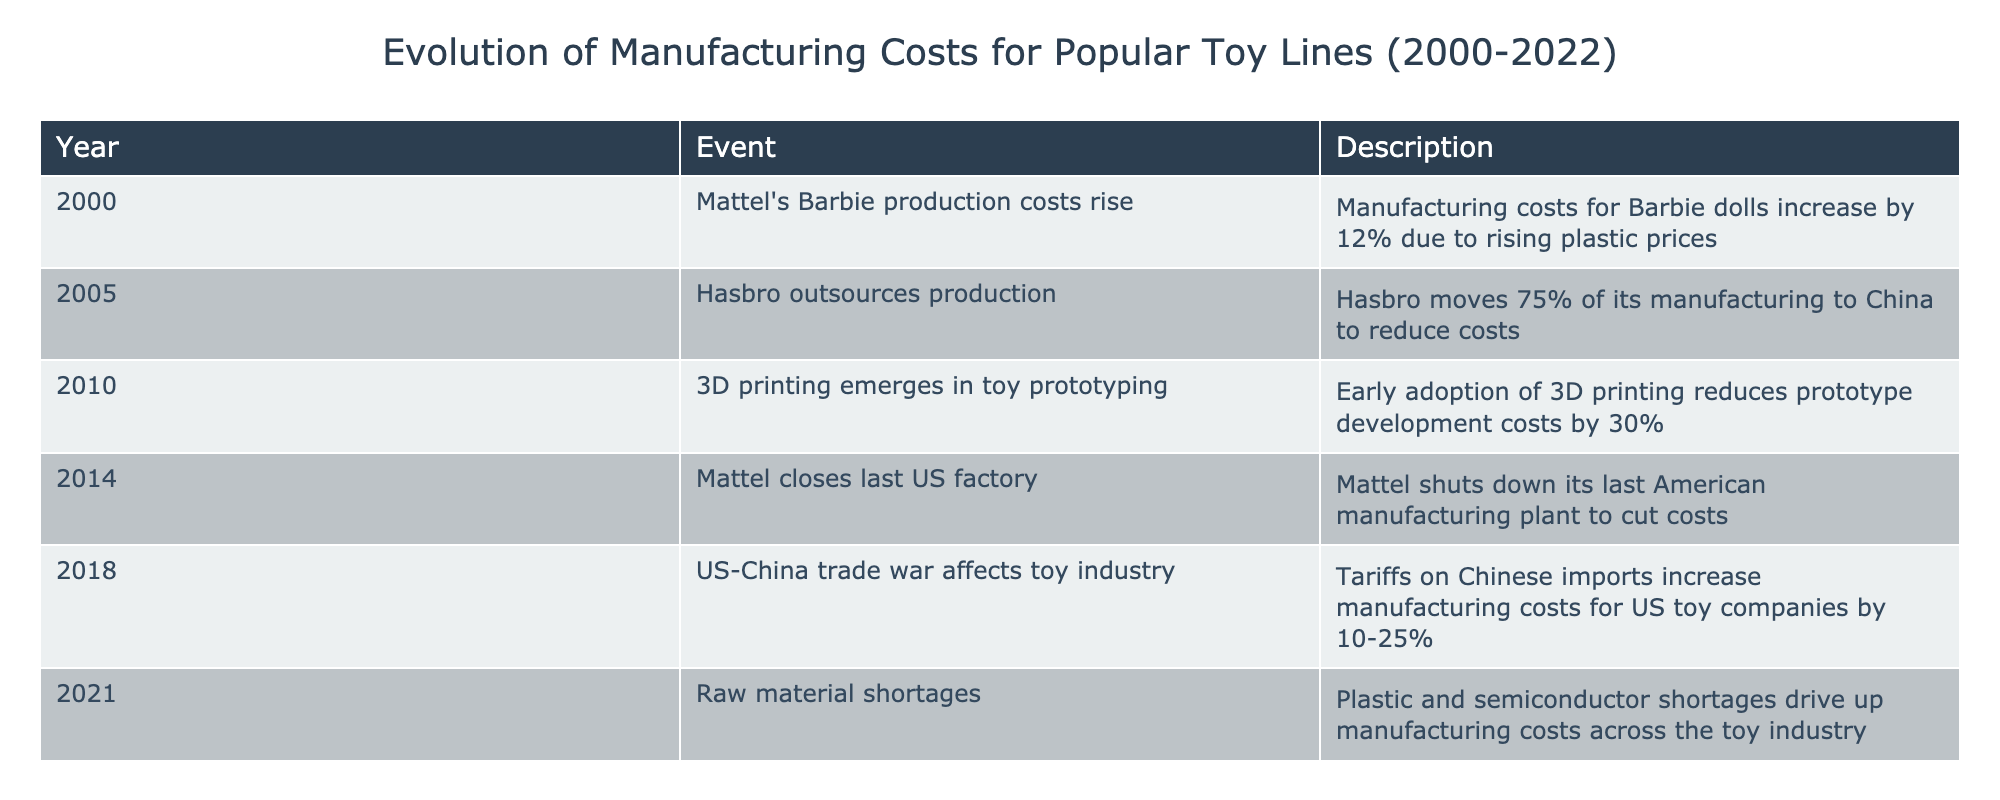What year did Hasbro outsource 75% of its production? Referring to the table, Hasbro outsourced its production in the year 2005. This can be directly seen in the “Year” column corresponding to the event mentioned.
Answer: 2005 What percentage did Mattel’s Barbie production costs rise in 2000? According to the table, Mattel's Barbie production costs rose by 12% in the year 2000. This information is explicitly stated in the "Description" column for that year.
Answer: 12% Did Mattel close its last US factory before or after 2014? The table clearly states that Mattel closed its last US factory in 2014. Therefore, the event occurred in the same year, so it cannot be before 2014.
Answer: After What was the range of increased manufacturing costs due to tariffs in 2018? From the table, the US-China trade war in 2018 resulted in increased manufacturing costs for US toy companies by between 10% and 25%. This range is provided in the details for that event.
Answer: 10-25% How much did prototype development costs decrease when 3D printing emerged? The table notes that the early adoption of 3D printing reduced prototype development costs by 30%. This figure is directly mentioned in the related event description.
Answer: 30% What is the total percentage of manufacturing cost increases indicated in the table from 2000 to 2021? The increases noted are: 12% for Barbie in 2000, 10-25% (let's take an average of 17.5%) for tariffs in 2018, and no specific percentages are given for 2021, thus summing these up gives us: 12 + 17.5 = 29.5%. The total percentage of confirmed increases is therefore 29.5%.
Answer: 29.5% Was there any specific event listed in the table that indicated raw material shortages? Yes, the table mentions a raw material shortage in 2021 due to plastic and semiconductor shortages driving up costs. This is clearly outlined as a separate entry within the timeline.
Answer: Yes What factors contributed to Mattel shutting down its last American manufacturing plant in 2014? According to the table, the primary reason listed for Mattel's decision to close its last US factory in 2014 was to cut costs, which indicates a focus on reducing manufacturing expenses amidst rising costs.
Answer: To cut costs What was the impact of the US-China trade war on the manufacturing costs for US toy companies? The table specifies that the US-China trade war in 2018 led to a manufacturing cost increase of 10-25% due to tariffs on Chinese imports. This is a direct cause-and-effect relationship highlighted in the event.
Answer: Increase of 10-25% 